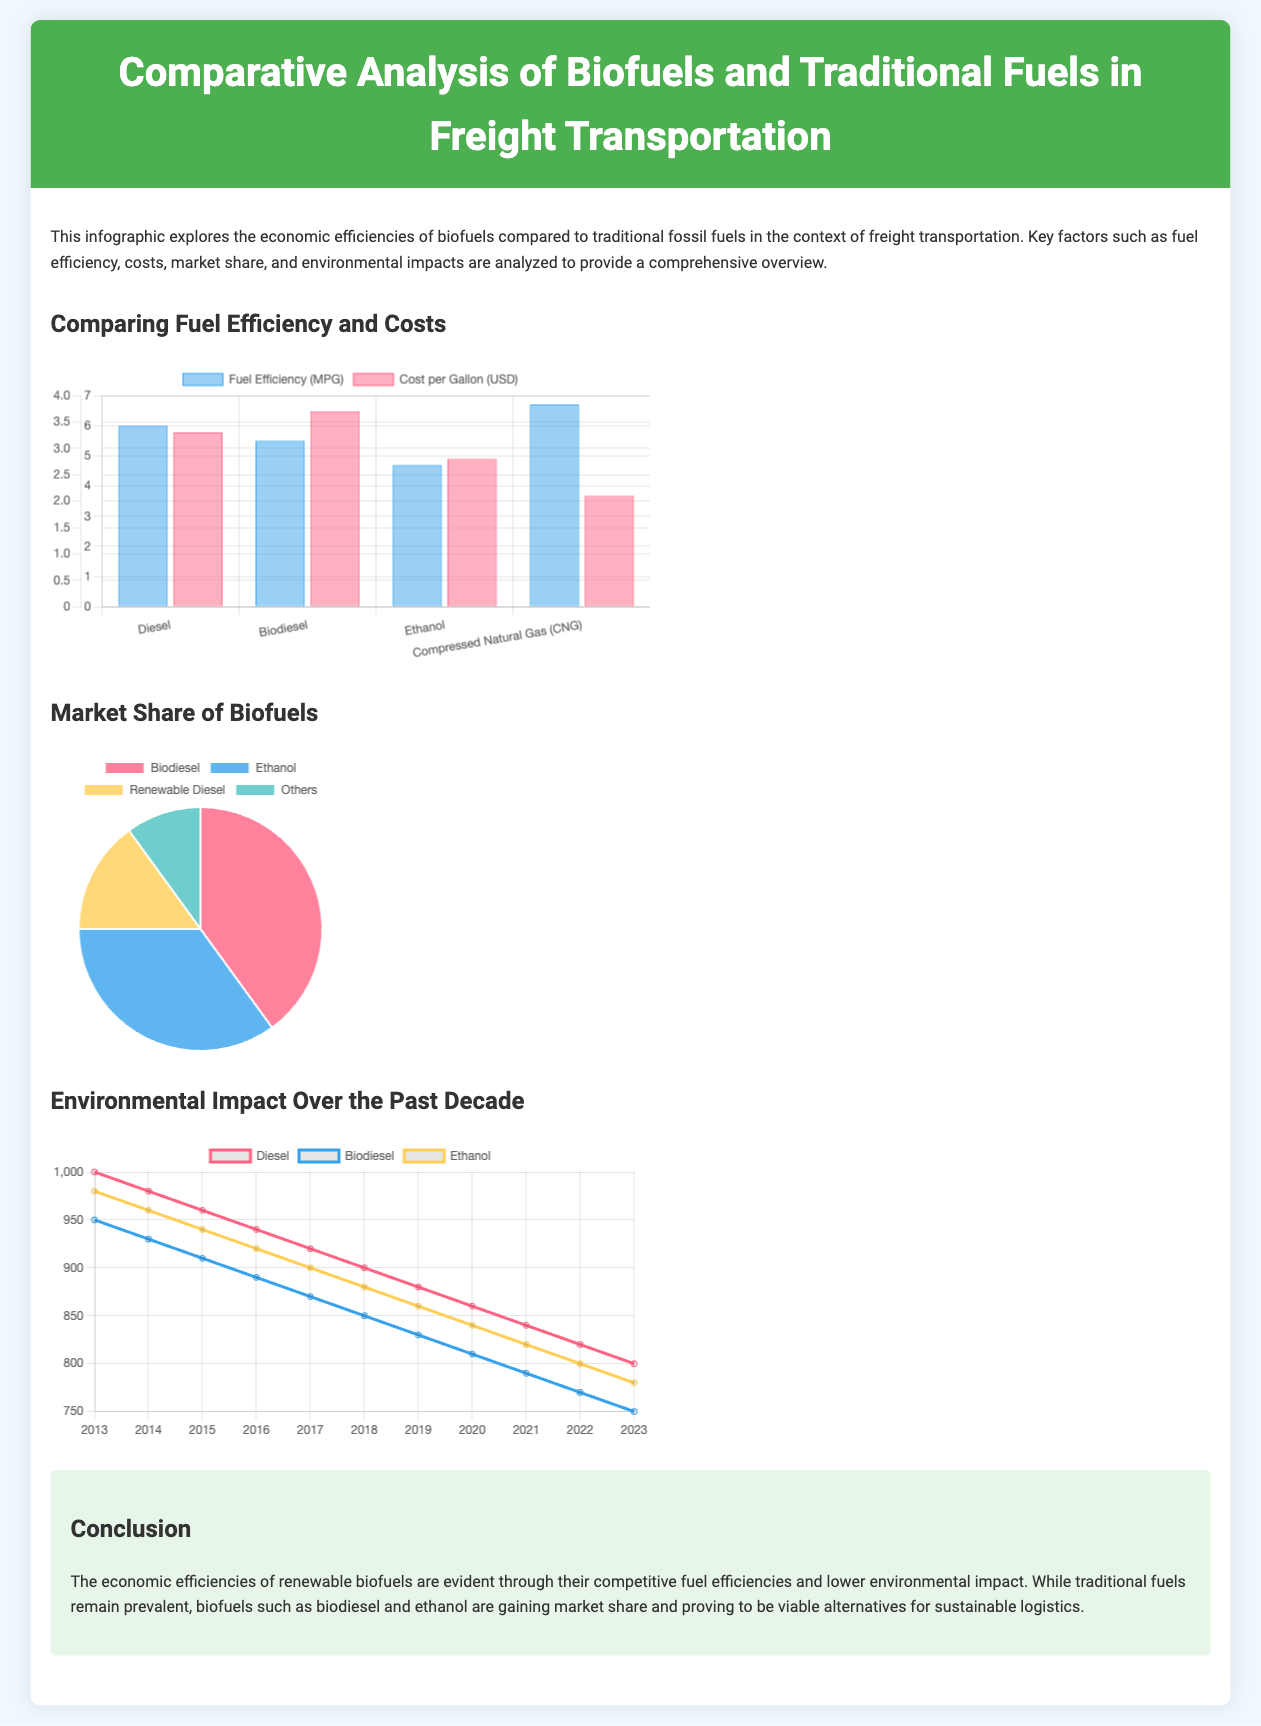What fuel has the highest efficiency? The fuel chart indicates that Compressed Natural Gas (CNG) has the highest efficiency at 6.7 MPG.
Answer: Compressed Natural Gas (CNG) What is the cost per gallon of ethanol? The chart shows that the cost per gallon of ethanol is $2.80.
Answer: $2.80 What is the market share percentage of biodiesel? The pie chart illustrates that biodiesel holds a 40% market share.
Answer: 40% In which year were carbon emissions from biodiesel the lowest? The line chart indicates that carbon emissions from biodiesel were at their lowest in 2023, at 750 million metric tons.
Answer: 2023 What was the carbon emission level of diesel in 2016? The chart shows that in 2016, diesel had a carbon emission level of 940 million metric tons.
Answer: 940 Which biofuel has the second-largest market share? According to the chart, ethanol has the second-largest market share at 35%.
Answer: Ethanol What trend is observed in carbon emissions from traditional diesel over the last decade? The line chart displays a decreasing trend in carbon emissions from traditional diesel over the last decade.
Answer: Decreasing How many types of biofuels are represented in the market share chart? The market share chart represents four types of biofuels.
Answer: Four What is the overall conclusion presented in the infographic? The conclusion states that economic efficiencies of renewable biofuels are evident through competitive fuel efficiencies and lower environmental impact.
Answer: Economic efficiencies of renewable biofuels are evident 